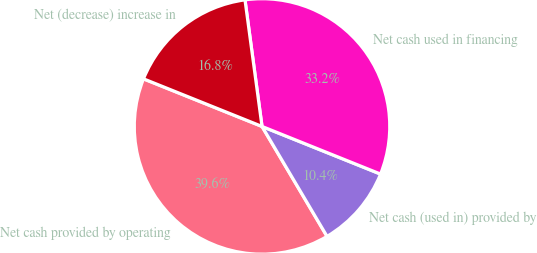<chart> <loc_0><loc_0><loc_500><loc_500><pie_chart><fcel>Net cash provided by operating<fcel>Net cash (used in) provided by<fcel>Net cash used in financing<fcel>Net (decrease) increase in<nl><fcel>39.58%<fcel>10.42%<fcel>33.21%<fcel>16.79%<nl></chart> 